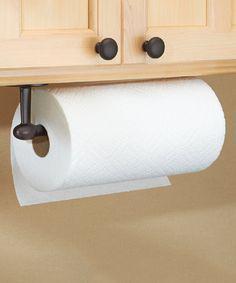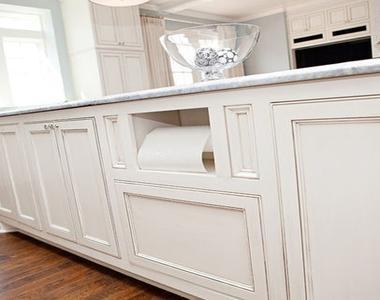The first image is the image on the left, the second image is the image on the right. Examine the images to the left and right. Is the description "The left image contains no more than one paper towel roll." accurate? Answer yes or no. Yes. The first image is the image on the left, the second image is the image on the right. Considering the images on both sides, is "One of the paper towel rolls is tucked under the upper cabinet." valid? Answer yes or no. Yes. 